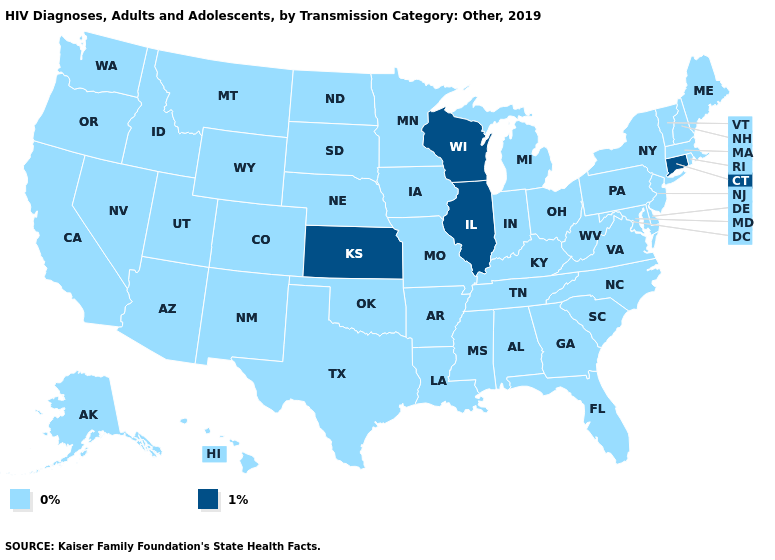What is the value of Arkansas?
Keep it brief. 0%. Does Connecticut have the highest value in the USA?
Write a very short answer. Yes. What is the lowest value in the USA?
Short answer required. 0%. What is the lowest value in states that border Michigan?
Be succinct. 0%. What is the value of Oklahoma?
Give a very brief answer. 0%. Does the map have missing data?
Concise answer only. No. How many symbols are there in the legend?
Answer briefly. 2. What is the value of Hawaii?
Concise answer only. 0%. Name the states that have a value in the range 0%?
Keep it brief. Alabama, Alaska, Arizona, Arkansas, California, Colorado, Delaware, Florida, Georgia, Hawaii, Idaho, Indiana, Iowa, Kentucky, Louisiana, Maine, Maryland, Massachusetts, Michigan, Minnesota, Mississippi, Missouri, Montana, Nebraska, Nevada, New Hampshire, New Jersey, New Mexico, New York, North Carolina, North Dakota, Ohio, Oklahoma, Oregon, Pennsylvania, Rhode Island, South Carolina, South Dakota, Tennessee, Texas, Utah, Vermont, Virginia, Washington, West Virginia, Wyoming. Which states have the lowest value in the USA?
Write a very short answer. Alabama, Alaska, Arizona, Arkansas, California, Colorado, Delaware, Florida, Georgia, Hawaii, Idaho, Indiana, Iowa, Kentucky, Louisiana, Maine, Maryland, Massachusetts, Michigan, Minnesota, Mississippi, Missouri, Montana, Nebraska, Nevada, New Hampshire, New Jersey, New Mexico, New York, North Carolina, North Dakota, Ohio, Oklahoma, Oregon, Pennsylvania, Rhode Island, South Carolina, South Dakota, Tennessee, Texas, Utah, Vermont, Virginia, Washington, West Virginia, Wyoming. Which states have the lowest value in the MidWest?
Concise answer only. Indiana, Iowa, Michigan, Minnesota, Missouri, Nebraska, North Dakota, Ohio, South Dakota. Does the map have missing data?
Quick response, please. No. Name the states that have a value in the range 0%?
Keep it brief. Alabama, Alaska, Arizona, Arkansas, California, Colorado, Delaware, Florida, Georgia, Hawaii, Idaho, Indiana, Iowa, Kentucky, Louisiana, Maine, Maryland, Massachusetts, Michigan, Minnesota, Mississippi, Missouri, Montana, Nebraska, Nevada, New Hampshire, New Jersey, New Mexico, New York, North Carolina, North Dakota, Ohio, Oklahoma, Oregon, Pennsylvania, Rhode Island, South Carolina, South Dakota, Tennessee, Texas, Utah, Vermont, Virginia, Washington, West Virginia, Wyoming. Which states have the lowest value in the Northeast?
Keep it brief. Maine, Massachusetts, New Hampshire, New Jersey, New York, Pennsylvania, Rhode Island, Vermont. What is the lowest value in the USA?
Quick response, please. 0%. 